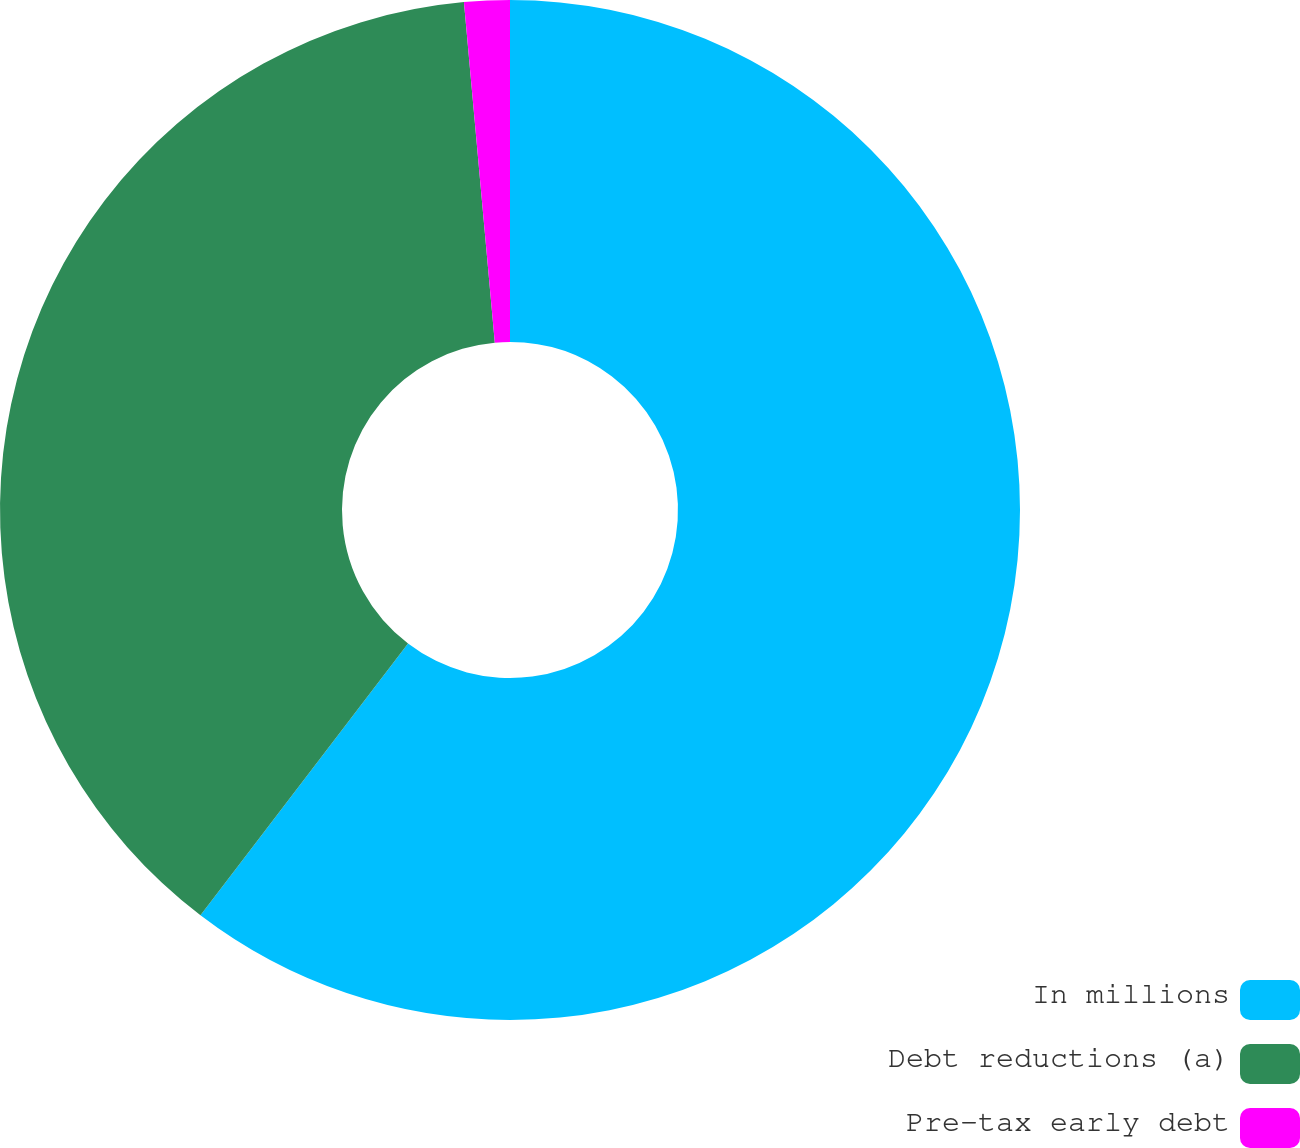Convert chart to OTSL. <chart><loc_0><loc_0><loc_500><loc_500><pie_chart><fcel>In millions<fcel>Debt reductions (a)<fcel>Pre-tax early debt<nl><fcel>60.38%<fcel>38.18%<fcel>1.44%<nl></chart> 